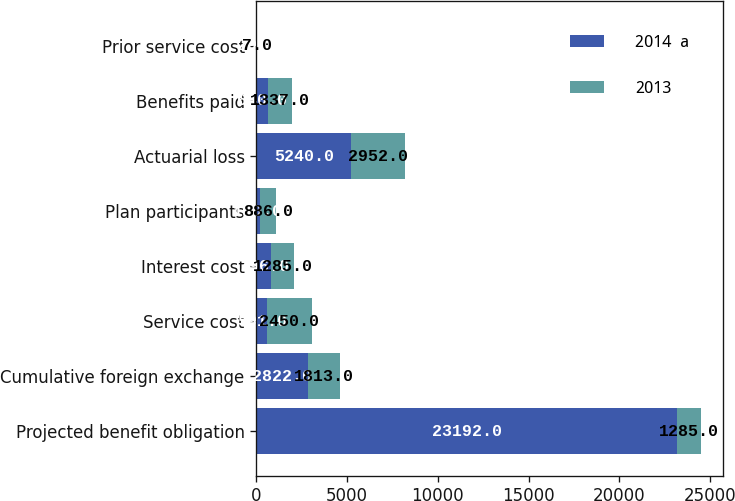Convert chart. <chart><loc_0><loc_0><loc_500><loc_500><stacked_bar_chart><ecel><fcel>Projected benefit obligation<fcel>Cumulative foreign exchange<fcel>Service cost<fcel>Interest cost<fcel>Plan participants<fcel>Actuarial loss<fcel>Benefits paid<fcel>Prior service cost<nl><fcel>2014  a<fcel>23192<fcel>2822<fcel>591<fcel>796<fcel>180<fcel>5240<fcel>640<fcel>29<nl><fcel>2013<fcel>1285<fcel>1813<fcel>2450<fcel>1285<fcel>886<fcel>2952<fcel>1337<fcel>7<nl></chart> 